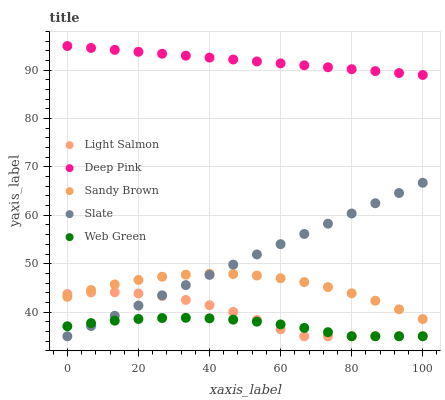Does Web Green have the minimum area under the curve?
Answer yes or no. Yes. Does Deep Pink have the maximum area under the curve?
Answer yes or no. Yes. Does Sandy Brown have the minimum area under the curve?
Answer yes or no. No. Does Sandy Brown have the maximum area under the curve?
Answer yes or no. No. Is Slate the smoothest?
Answer yes or no. Yes. Is Light Salmon the roughest?
Answer yes or no. Yes. Is Deep Pink the smoothest?
Answer yes or no. No. Is Deep Pink the roughest?
Answer yes or no. No. Does Light Salmon have the lowest value?
Answer yes or no. Yes. Does Sandy Brown have the lowest value?
Answer yes or no. No. Does Deep Pink have the highest value?
Answer yes or no. Yes. Does Sandy Brown have the highest value?
Answer yes or no. No. Is Web Green less than Deep Pink?
Answer yes or no. Yes. Is Deep Pink greater than Web Green?
Answer yes or no. Yes. Does Sandy Brown intersect Slate?
Answer yes or no. Yes. Is Sandy Brown less than Slate?
Answer yes or no. No. Is Sandy Brown greater than Slate?
Answer yes or no. No. Does Web Green intersect Deep Pink?
Answer yes or no. No. 